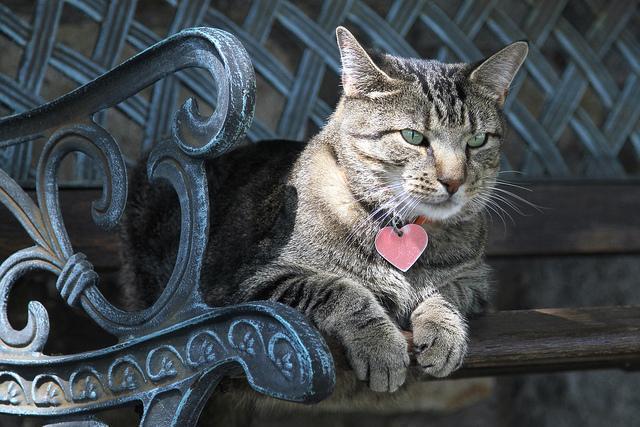What is the purpose of the heart around the cats neck?
From the following set of four choices, select the accurate answer to respond to the question.
Options: Protection, visibility, fashion, identification. Identification. 